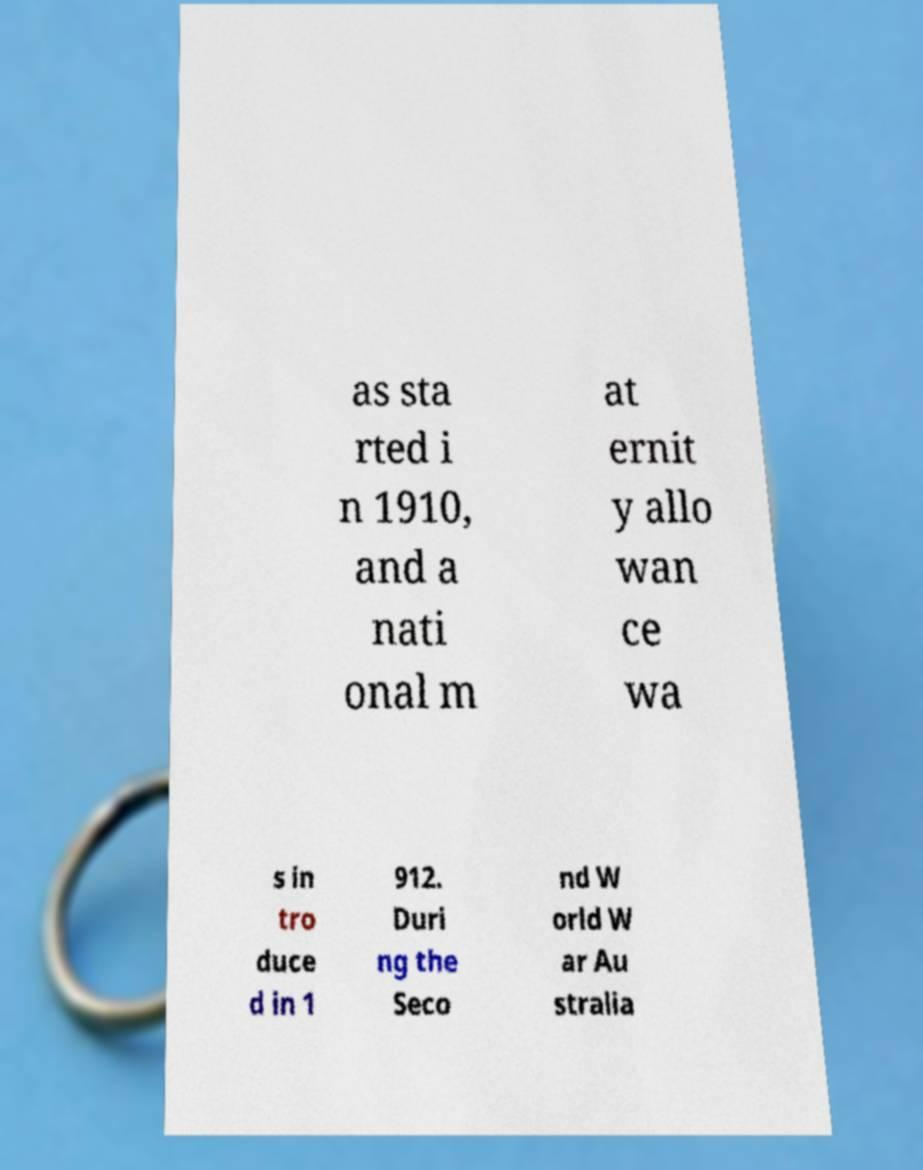Can you accurately transcribe the text from the provided image for me? as sta rted i n 1910, and a nati onal m at ernit y allo wan ce wa s in tro duce d in 1 912. Duri ng the Seco nd W orld W ar Au stralia 